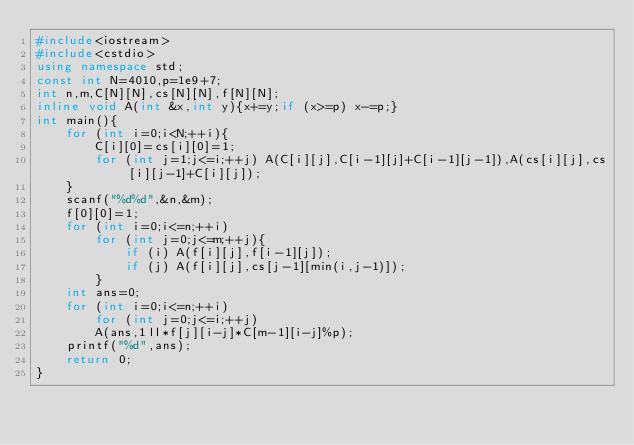<code> <loc_0><loc_0><loc_500><loc_500><_C++_>#include<iostream>
#include<cstdio>
using namespace std;
const int N=4010,p=1e9+7;
int n,m,C[N][N],cs[N][N],f[N][N];
inline void A(int &x,int y){x+=y;if (x>=p) x-=p;}
int main(){
	for (int i=0;i<N;++i){
		C[i][0]=cs[i][0]=1;
		for (int j=1;j<=i;++j) A(C[i][j],C[i-1][j]+C[i-1][j-1]),A(cs[i][j],cs[i][j-1]+C[i][j]);
	}
	scanf("%d%d",&n,&m);
	f[0][0]=1;
	for (int i=0;i<=n;++i)
		for (int j=0;j<=m;++j){
			if (i) A(f[i][j],f[i-1][j]);
			if (j) A(f[i][j],cs[j-1][min(i,j-1)]);
		}
	int ans=0;
	for (int i=0;i<=n;++i)
		for (int j=0;j<=i;++j)
		A(ans,1ll*f[j][i-j]*C[m-1][i-j]%p);
	printf("%d",ans);
	return 0;
}</code> 